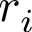Convert formula to latex. <formula><loc_0><loc_0><loc_500><loc_500>r _ { i }</formula> 